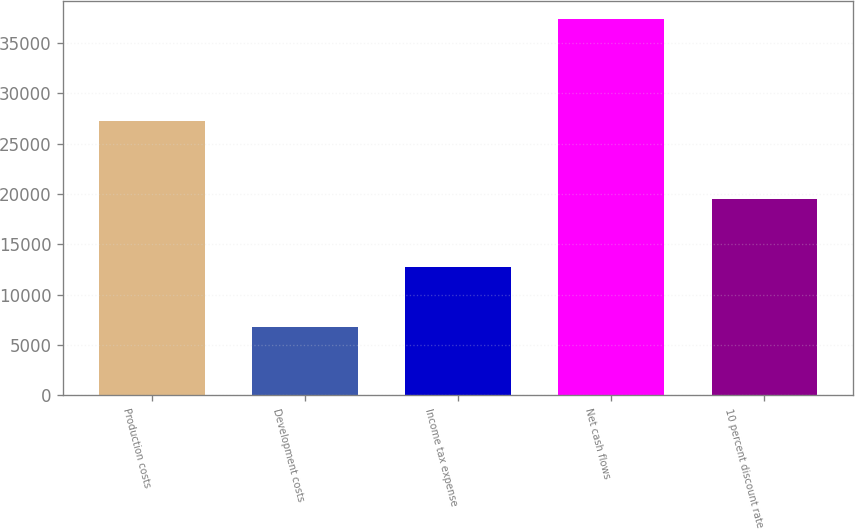Convert chart to OTSL. <chart><loc_0><loc_0><loc_500><loc_500><bar_chart><fcel>Production costs<fcel>Development costs<fcel>Income tax expense<fcel>Net cash flows<fcel>10 percent discount rate<nl><fcel>27230<fcel>6768<fcel>12740<fcel>37322<fcel>19464<nl></chart> 